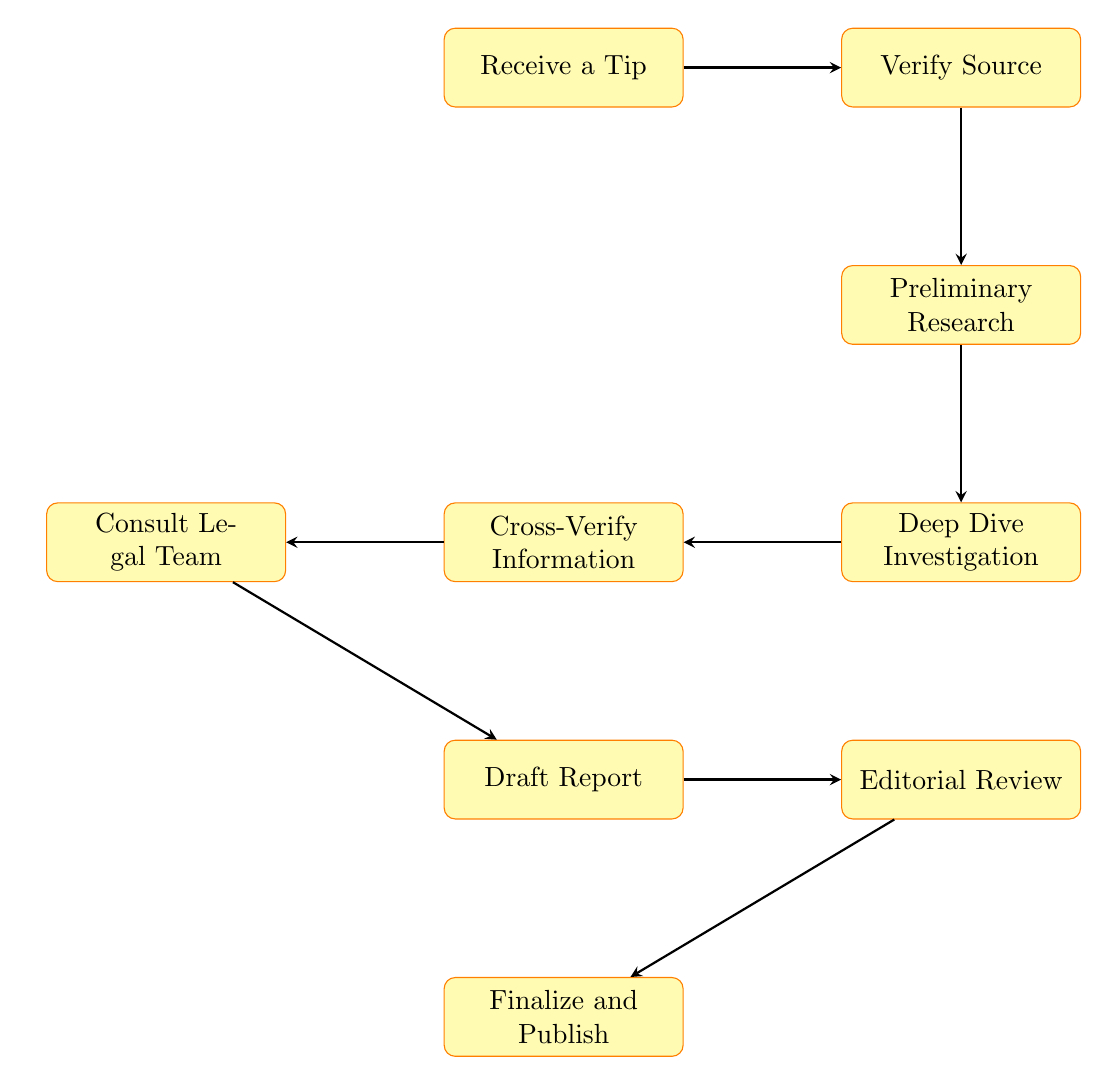What is the first step in the investigation process? The first step is indicated by the top node labeled "Receive a Tip," which begins the flow of investigation actions.
Answer: Receive a Tip How many processes are in the flowchart? By counting each distinct process node in the diagram, we find a total of 9 nodes, representing each step of the investigative process.
Answer: 9 What follows after verifying the source? The arrow from "Verify Source" leads directly down to "Preliminary Research," establishing the next step in the investigation.
Answer: Preliminary Research Which step involves gathering information from independent sources? The "Cross-Verify Information" node specifically describes the process of checking consistency and accuracy with multiple independent sources.
Answer: Cross-Verify Information What must be consulted before drafting the report? Prior to drafting, the process flows from "Cross-Verify Information" to "Consult Legal Team," indicating a necessary consultation for legal compliance.
Answer: Consult Legal Team What is the last step before publication? The final step before publishing is indicated by "Finalize and Publish," which reflects the culmination of all prior work into a published report.
Answer: Finalize and Publish Which step includes feedback from editors? The "Editorial Review" node explicitly involves submitting the draft report for review by editors and senior journalists to ensure accuracy and integrity.
Answer: Editorial Review How many nodes are directly connected to the "Draft Report"? There are two nodes directly connected to "Draft Report": "Consult Legal Team" and "Editorial Review," thus forming a branched path from this step.
Answer: 2 What is the main purpose of the "Deep Dive Investigation"? The purpose stated in the node "Deep Dive Investigation" is to conduct in-depth investigations including interviews, document analysis, and data collection, which is critical for thorough reporting.
Answer: Conduct thorough investigations 